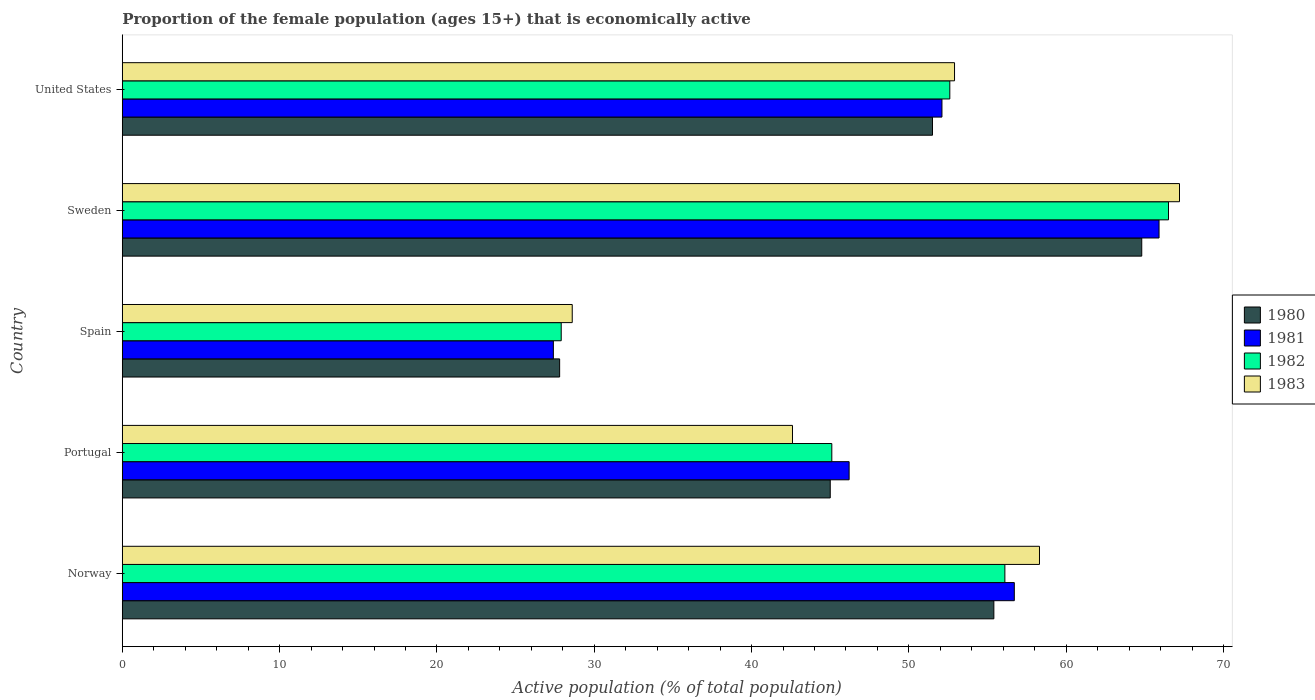How many groups of bars are there?
Your response must be concise. 5. Are the number of bars on each tick of the Y-axis equal?
Provide a short and direct response. Yes. How many bars are there on the 3rd tick from the bottom?
Offer a very short reply. 4. What is the label of the 4th group of bars from the top?
Your answer should be very brief. Portugal. In how many cases, is the number of bars for a given country not equal to the number of legend labels?
Keep it short and to the point. 0. What is the proportion of the female population that is economically active in 1980 in Norway?
Your answer should be very brief. 55.4. Across all countries, what is the maximum proportion of the female population that is economically active in 1980?
Offer a very short reply. 64.8. Across all countries, what is the minimum proportion of the female population that is economically active in 1981?
Give a very brief answer. 27.4. In which country was the proportion of the female population that is economically active in 1982 maximum?
Your answer should be very brief. Sweden. In which country was the proportion of the female population that is economically active in 1981 minimum?
Offer a very short reply. Spain. What is the total proportion of the female population that is economically active in 1982 in the graph?
Provide a succinct answer. 248.2. What is the difference between the proportion of the female population that is economically active in 1982 in Portugal and that in United States?
Your answer should be compact. -7.5. What is the difference between the proportion of the female population that is economically active in 1981 in United States and the proportion of the female population that is economically active in 1983 in Norway?
Your response must be concise. -6.2. What is the average proportion of the female population that is economically active in 1983 per country?
Provide a short and direct response. 49.92. What is the difference between the proportion of the female population that is economically active in 1983 and proportion of the female population that is economically active in 1982 in Norway?
Ensure brevity in your answer.  2.2. In how many countries, is the proportion of the female population that is economically active in 1982 greater than 42 %?
Ensure brevity in your answer.  4. What is the ratio of the proportion of the female population that is economically active in 1980 in Portugal to that in Sweden?
Keep it short and to the point. 0.69. What is the difference between the highest and the second highest proportion of the female population that is economically active in 1981?
Your answer should be compact. 9.2. What is the difference between the highest and the lowest proportion of the female population that is economically active in 1982?
Give a very brief answer. 38.6. In how many countries, is the proportion of the female population that is economically active in 1983 greater than the average proportion of the female population that is economically active in 1983 taken over all countries?
Provide a short and direct response. 3. What does the 2nd bar from the bottom in Sweden represents?
Provide a succinct answer. 1981. Is it the case that in every country, the sum of the proportion of the female population that is economically active in 1981 and proportion of the female population that is economically active in 1980 is greater than the proportion of the female population that is economically active in 1982?
Give a very brief answer. Yes. Are all the bars in the graph horizontal?
Offer a very short reply. Yes. Does the graph contain grids?
Your answer should be very brief. No. Where does the legend appear in the graph?
Your answer should be compact. Center right. How many legend labels are there?
Offer a terse response. 4. How are the legend labels stacked?
Your answer should be very brief. Vertical. What is the title of the graph?
Offer a very short reply. Proportion of the female population (ages 15+) that is economically active. Does "2004" appear as one of the legend labels in the graph?
Provide a short and direct response. No. What is the label or title of the X-axis?
Your answer should be compact. Active population (% of total population). What is the Active population (% of total population) in 1980 in Norway?
Offer a terse response. 55.4. What is the Active population (% of total population) in 1981 in Norway?
Keep it short and to the point. 56.7. What is the Active population (% of total population) in 1982 in Norway?
Offer a very short reply. 56.1. What is the Active population (% of total population) in 1983 in Norway?
Your response must be concise. 58.3. What is the Active population (% of total population) in 1980 in Portugal?
Provide a short and direct response. 45. What is the Active population (% of total population) of 1981 in Portugal?
Provide a succinct answer. 46.2. What is the Active population (% of total population) in 1982 in Portugal?
Make the answer very short. 45.1. What is the Active population (% of total population) in 1983 in Portugal?
Your answer should be very brief. 42.6. What is the Active population (% of total population) in 1980 in Spain?
Your answer should be very brief. 27.8. What is the Active population (% of total population) of 1981 in Spain?
Keep it short and to the point. 27.4. What is the Active population (% of total population) in 1982 in Spain?
Provide a short and direct response. 27.9. What is the Active population (% of total population) of 1983 in Spain?
Your response must be concise. 28.6. What is the Active population (% of total population) of 1980 in Sweden?
Keep it short and to the point. 64.8. What is the Active population (% of total population) of 1981 in Sweden?
Keep it short and to the point. 65.9. What is the Active population (% of total population) of 1982 in Sweden?
Provide a succinct answer. 66.5. What is the Active population (% of total population) of 1983 in Sweden?
Your answer should be very brief. 67.2. What is the Active population (% of total population) in 1980 in United States?
Provide a succinct answer. 51.5. What is the Active population (% of total population) in 1981 in United States?
Keep it short and to the point. 52.1. What is the Active population (% of total population) of 1982 in United States?
Your response must be concise. 52.6. What is the Active population (% of total population) in 1983 in United States?
Ensure brevity in your answer.  52.9. Across all countries, what is the maximum Active population (% of total population) in 1980?
Ensure brevity in your answer.  64.8. Across all countries, what is the maximum Active population (% of total population) of 1981?
Provide a short and direct response. 65.9. Across all countries, what is the maximum Active population (% of total population) in 1982?
Offer a very short reply. 66.5. Across all countries, what is the maximum Active population (% of total population) of 1983?
Your answer should be compact. 67.2. Across all countries, what is the minimum Active population (% of total population) in 1980?
Your response must be concise. 27.8. Across all countries, what is the minimum Active population (% of total population) of 1981?
Make the answer very short. 27.4. Across all countries, what is the minimum Active population (% of total population) of 1982?
Give a very brief answer. 27.9. Across all countries, what is the minimum Active population (% of total population) in 1983?
Provide a short and direct response. 28.6. What is the total Active population (% of total population) in 1980 in the graph?
Your answer should be very brief. 244.5. What is the total Active population (% of total population) of 1981 in the graph?
Your response must be concise. 248.3. What is the total Active population (% of total population) in 1982 in the graph?
Keep it short and to the point. 248.2. What is the total Active population (% of total population) in 1983 in the graph?
Offer a terse response. 249.6. What is the difference between the Active population (% of total population) of 1982 in Norway and that in Portugal?
Your answer should be very brief. 11. What is the difference between the Active population (% of total population) of 1980 in Norway and that in Spain?
Your answer should be very brief. 27.6. What is the difference between the Active population (% of total population) in 1981 in Norway and that in Spain?
Provide a short and direct response. 29.3. What is the difference between the Active population (% of total population) of 1982 in Norway and that in Spain?
Keep it short and to the point. 28.2. What is the difference between the Active population (% of total population) in 1983 in Norway and that in Spain?
Provide a succinct answer. 29.7. What is the difference between the Active population (% of total population) in 1980 in Norway and that in Sweden?
Offer a very short reply. -9.4. What is the difference between the Active population (% of total population) in 1981 in Norway and that in Sweden?
Your response must be concise. -9.2. What is the difference between the Active population (% of total population) of 1983 in Norway and that in Sweden?
Provide a succinct answer. -8.9. What is the difference between the Active population (% of total population) in 1981 in Norway and that in United States?
Your answer should be very brief. 4.6. What is the difference between the Active population (% of total population) in 1980 in Portugal and that in Sweden?
Offer a very short reply. -19.8. What is the difference between the Active population (% of total population) in 1981 in Portugal and that in Sweden?
Keep it short and to the point. -19.7. What is the difference between the Active population (% of total population) in 1982 in Portugal and that in Sweden?
Keep it short and to the point. -21.4. What is the difference between the Active population (% of total population) in 1983 in Portugal and that in Sweden?
Provide a succinct answer. -24.6. What is the difference between the Active population (% of total population) in 1980 in Portugal and that in United States?
Offer a very short reply. -6.5. What is the difference between the Active population (% of total population) of 1981 in Portugal and that in United States?
Your answer should be compact. -5.9. What is the difference between the Active population (% of total population) in 1982 in Portugal and that in United States?
Provide a succinct answer. -7.5. What is the difference between the Active population (% of total population) in 1983 in Portugal and that in United States?
Keep it short and to the point. -10.3. What is the difference between the Active population (% of total population) in 1980 in Spain and that in Sweden?
Ensure brevity in your answer.  -37. What is the difference between the Active population (% of total population) of 1981 in Spain and that in Sweden?
Provide a short and direct response. -38.5. What is the difference between the Active population (% of total population) in 1982 in Spain and that in Sweden?
Offer a very short reply. -38.6. What is the difference between the Active population (% of total population) in 1983 in Spain and that in Sweden?
Your answer should be compact. -38.6. What is the difference between the Active population (% of total population) in 1980 in Spain and that in United States?
Provide a succinct answer. -23.7. What is the difference between the Active population (% of total population) of 1981 in Spain and that in United States?
Offer a terse response. -24.7. What is the difference between the Active population (% of total population) of 1982 in Spain and that in United States?
Provide a succinct answer. -24.7. What is the difference between the Active population (% of total population) of 1983 in Spain and that in United States?
Provide a succinct answer. -24.3. What is the difference between the Active population (% of total population) in 1980 in Sweden and that in United States?
Your response must be concise. 13.3. What is the difference between the Active population (% of total population) in 1981 in Sweden and that in United States?
Your response must be concise. 13.8. What is the difference between the Active population (% of total population) of 1983 in Sweden and that in United States?
Provide a succinct answer. 14.3. What is the difference between the Active population (% of total population) in 1980 in Norway and the Active population (% of total population) in 1982 in Portugal?
Your answer should be compact. 10.3. What is the difference between the Active population (% of total population) in 1980 in Norway and the Active population (% of total population) in 1983 in Portugal?
Your response must be concise. 12.8. What is the difference between the Active population (% of total population) in 1981 in Norway and the Active population (% of total population) in 1982 in Portugal?
Offer a terse response. 11.6. What is the difference between the Active population (% of total population) in 1982 in Norway and the Active population (% of total population) in 1983 in Portugal?
Your answer should be compact. 13.5. What is the difference between the Active population (% of total population) in 1980 in Norway and the Active population (% of total population) in 1982 in Spain?
Your answer should be very brief. 27.5. What is the difference between the Active population (% of total population) in 1980 in Norway and the Active population (% of total population) in 1983 in Spain?
Keep it short and to the point. 26.8. What is the difference between the Active population (% of total population) in 1981 in Norway and the Active population (% of total population) in 1982 in Spain?
Your response must be concise. 28.8. What is the difference between the Active population (% of total population) in 1981 in Norway and the Active population (% of total population) in 1983 in Spain?
Give a very brief answer. 28.1. What is the difference between the Active population (% of total population) in 1980 in Norway and the Active population (% of total population) in 1981 in Sweden?
Your response must be concise. -10.5. What is the difference between the Active population (% of total population) in 1981 in Norway and the Active population (% of total population) in 1982 in Sweden?
Keep it short and to the point. -9.8. What is the difference between the Active population (% of total population) of 1982 in Norway and the Active population (% of total population) of 1983 in Sweden?
Give a very brief answer. -11.1. What is the difference between the Active population (% of total population) of 1980 in Norway and the Active population (% of total population) of 1981 in United States?
Your answer should be very brief. 3.3. What is the difference between the Active population (% of total population) in 1980 in Norway and the Active population (% of total population) in 1982 in United States?
Your response must be concise. 2.8. What is the difference between the Active population (% of total population) of 1981 in Norway and the Active population (% of total population) of 1982 in United States?
Your answer should be very brief. 4.1. What is the difference between the Active population (% of total population) of 1982 in Norway and the Active population (% of total population) of 1983 in United States?
Offer a very short reply. 3.2. What is the difference between the Active population (% of total population) in 1980 in Portugal and the Active population (% of total population) in 1981 in Spain?
Provide a short and direct response. 17.6. What is the difference between the Active population (% of total population) of 1982 in Portugal and the Active population (% of total population) of 1983 in Spain?
Make the answer very short. 16.5. What is the difference between the Active population (% of total population) in 1980 in Portugal and the Active population (% of total population) in 1981 in Sweden?
Make the answer very short. -20.9. What is the difference between the Active population (% of total population) in 1980 in Portugal and the Active population (% of total population) in 1982 in Sweden?
Ensure brevity in your answer.  -21.5. What is the difference between the Active population (% of total population) in 1980 in Portugal and the Active population (% of total population) in 1983 in Sweden?
Offer a very short reply. -22.2. What is the difference between the Active population (% of total population) in 1981 in Portugal and the Active population (% of total population) in 1982 in Sweden?
Keep it short and to the point. -20.3. What is the difference between the Active population (% of total population) in 1981 in Portugal and the Active population (% of total population) in 1983 in Sweden?
Provide a succinct answer. -21. What is the difference between the Active population (% of total population) of 1982 in Portugal and the Active population (% of total population) of 1983 in Sweden?
Your response must be concise. -22.1. What is the difference between the Active population (% of total population) in 1980 in Portugal and the Active population (% of total population) in 1981 in United States?
Your answer should be compact. -7.1. What is the difference between the Active population (% of total population) in 1980 in Portugal and the Active population (% of total population) in 1983 in United States?
Provide a short and direct response. -7.9. What is the difference between the Active population (% of total population) in 1981 in Portugal and the Active population (% of total population) in 1982 in United States?
Give a very brief answer. -6.4. What is the difference between the Active population (% of total population) of 1981 in Portugal and the Active population (% of total population) of 1983 in United States?
Make the answer very short. -6.7. What is the difference between the Active population (% of total population) in 1982 in Portugal and the Active population (% of total population) in 1983 in United States?
Give a very brief answer. -7.8. What is the difference between the Active population (% of total population) of 1980 in Spain and the Active population (% of total population) of 1981 in Sweden?
Provide a short and direct response. -38.1. What is the difference between the Active population (% of total population) of 1980 in Spain and the Active population (% of total population) of 1982 in Sweden?
Give a very brief answer. -38.7. What is the difference between the Active population (% of total population) in 1980 in Spain and the Active population (% of total population) in 1983 in Sweden?
Make the answer very short. -39.4. What is the difference between the Active population (% of total population) of 1981 in Spain and the Active population (% of total population) of 1982 in Sweden?
Provide a short and direct response. -39.1. What is the difference between the Active population (% of total population) in 1981 in Spain and the Active population (% of total population) in 1983 in Sweden?
Your answer should be compact. -39.8. What is the difference between the Active population (% of total population) in 1982 in Spain and the Active population (% of total population) in 1983 in Sweden?
Ensure brevity in your answer.  -39.3. What is the difference between the Active population (% of total population) in 1980 in Spain and the Active population (% of total population) in 1981 in United States?
Ensure brevity in your answer.  -24.3. What is the difference between the Active population (% of total population) of 1980 in Spain and the Active population (% of total population) of 1982 in United States?
Make the answer very short. -24.8. What is the difference between the Active population (% of total population) of 1980 in Spain and the Active population (% of total population) of 1983 in United States?
Your response must be concise. -25.1. What is the difference between the Active population (% of total population) in 1981 in Spain and the Active population (% of total population) in 1982 in United States?
Your answer should be very brief. -25.2. What is the difference between the Active population (% of total population) in 1981 in Spain and the Active population (% of total population) in 1983 in United States?
Provide a short and direct response. -25.5. What is the difference between the Active population (% of total population) in 1982 in Spain and the Active population (% of total population) in 1983 in United States?
Provide a short and direct response. -25. What is the difference between the Active population (% of total population) in 1980 in Sweden and the Active population (% of total population) in 1983 in United States?
Offer a very short reply. 11.9. What is the difference between the Active population (% of total population) in 1981 in Sweden and the Active population (% of total population) in 1983 in United States?
Give a very brief answer. 13. What is the average Active population (% of total population) in 1980 per country?
Your response must be concise. 48.9. What is the average Active population (% of total population) in 1981 per country?
Offer a terse response. 49.66. What is the average Active population (% of total population) in 1982 per country?
Make the answer very short. 49.64. What is the average Active population (% of total population) in 1983 per country?
Your answer should be very brief. 49.92. What is the difference between the Active population (% of total population) in 1980 and Active population (% of total population) in 1983 in Norway?
Keep it short and to the point. -2.9. What is the difference between the Active population (% of total population) in 1981 and Active population (% of total population) in 1983 in Norway?
Provide a succinct answer. -1.6. What is the difference between the Active population (% of total population) of 1982 and Active population (% of total population) of 1983 in Norway?
Offer a terse response. -2.2. What is the difference between the Active population (% of total population) in 1981 and Active population (% of total population) in 1982 in Portugal?
Your response must be concise. 1.1. What is the difference between the Active population (% of total population) of 1980 and Active population (% of total population) of 1981 in Spain?
Your answer should be compact. 0.4. What is the difference between the Active population (% of total population) of 1980 and Active population (% of total population) of 1982 in Spain?
Ensure brevity in your answer.  -0.1. What is the difference between the Active population (% of total population) of 1981 and Active population (% of total population) of 1983 in Spain?
Offer a very short reply. -1.2. What is the difference between the Active population (% of total population) of 1980 and Active population (% of total population) of 1982 in Sweden?
Provide a short and direct response. -1.7. What is the difference between the Active population (% of total population) of 1981 and Active population (% of total population) of 1983 in Sweden?
Ensure brevity in your answer.  -1.3. What is the difference between the Active population (% of total population) of 1980 and Active population (% of total population) of 1981 in United States?
Provide a short and direct response. -0.6. What is the difference between the Active population (% of total population) in 1982 and Active population (% of total population) in 1983 in United States?
Keep it short and to the point. -0.3. What is the ratio of the Active population (% of total population) in 1980 in Norway to that in Portugal?
Keep it short and to the point. 1.23. What is the ratio of the Active population (% of total population) in 1981 in Norway to that in Portugal?
Provide a short and direct response. 1.23. What is the ratio of the Active population (% of total population) of 1982 in Norway to that in Portugal?
Your answer should be very brief. 1.24. What is the ratio of the Active population (% of total population) of 1983 in Norway to that in Portugal?
Provide a short and direct response. 1.37. What is the ratio of the Active population (% of total population) in 1980 in Norway to that in Spain?
Your response must be concise. 1.99. What is the ratio of the Active population (% of total population) of 1981 in Norway to that in Spain?
Provide a succinct answer. 2.07. What is the ratio of the Active population (% of total population) in 1982 in Norway to that in Spain?
Make the answer very short. 2.01. What is the ratio of the Active population (% of total population) in 1983 in Norway to that in Spain?
Make the answer very short. 2.04. What is the ratio of the Active population (% of total population) in 1980 in Norway to that in Sweden?
Ensure brevity in your answer.  0.85. What is the ratio of the Active population (% of total population) of 1981 in Norway to that in Sweden?
Your answer should be compact. 0.86. What is the ratio of the Active population (% of total population) of 1982 in Norway to that in Sweden?
Keep it short and to the point. 0.84. What is the ratio of the Active population (% of total population) in 1983 in Norway to that in Sweden?
Ensure brevity in your answer.  0.87. What is the ratio of the Active population (% of total population) in 1980 in Norway to that in United States?
Offer a very short reply. 1.08. What is the ratio of the Active population (% of total population) of 1981 in Norway to that in United States?
Make the answer very short. 1.09. What is the ratio of the Active population (% of total population) in 1982 in Norway to that in United States?
Your answer should be very brief. 1.07. What is the ratio of the Active population (% of total population) in 1983 in Norway to that in United States?
Keep it short and to the point. 1.1. What is the ratio of the Active population (% of total population) of 1980 in Portugal to that in Spain?
Offer a very short reply. 1.62. What is the ratio of the Active population (% of total population) of 1981 in Portugal to that in Spain?
Your answer should be very brief. 1.69. What is the ratio of the Active population (% of total population) of 1982 in Portugal to that in Spain?
Give a very brief answer. 1.62. What is the ratio of the Active population (% of total population) of 1983 in Portugal to that in Spain?
Keep it short and to the point. 1.49. What is the ratio of the Active population (% of total population) in 1980 in Portugal to that in Sweden?
Your answer should be compact. 0.69. What is the ratio of the Active population (% of total population) of 1981 in Portugal to that in Sweden?
Keep it short and to the point. 0.7. What is the ratio of the Active population (% of total population) of 1982 in Portugal to that in Sweden?
Your response must be concise. 0.68. What is the ratio of the Active population (% of total population) of 1983 in Portugal to that in Sweden?
Your response must be concise. 0.63. What is the ratio of the Active population (% of total population) in 1980 in Portugal to that in United States?
Your response must be concise. 0.87. What is the ratio of the Active population (% of total population) of 1981 in Portugal to that in United States?
Make the answer very short. 0.89. What is the ratio of the Active population (% of total population) of 1982 in Portugal to that in United States?
Make the answer very short. 0.86. What is the ratio of the Active population (% of total population) of 1983 in Portugal to that in United States?
Ensure brevity in your answer.  0.81. What is the ratio of the Active population (% of total population) of 1980 in Spain to that in Sweden?
Offer a very short reply. 0.43. What is the ratio of the Active population (% of total population) of 1981 in Spain to that in Sweden?
Keep it short and to the point. 0.42. What is the ratio of the Active population (% of total population) in 1982 in Spain to that in Sweden?
Provide a short and direct response. 0.42. What is the ratio of the Active population (% of total population) in 1983 in Spain to that in Sweden?
Provide a succinct answer. 0.43. What is the ratio of the Active population (% of total population) of 1980 in Spain to that in United States?
Provide a short and direct response. 0.54. What is the ratio of the Active population (% of total population) of 1981 in Spain to that in United States?
Offer a very short reply. 0.53. What is the ratio of the Active population (% of total population) in 1982 in Spain to that in United States?
Ensure brevity in your answer.  0.53. What is the ratio of the Active population (% of total population) in 1983 in Spain to that in United States?
Provide a short and direct response. 0.54. What is the ratio of the Active population (% of total population) of 1980 in Sweden to that in United States?
Your answer should be compact. 1.26. What is the ratio of the Active population (% of total population) of 1981 in Sweden to that in United States?
Your answer should be compact. 1.26. What is the ratio of the Active population (% of total population) in 1982 in Sweden to that in United States?
Offer a very short reply. 1.26. What is the ratio of the Active population (% of total population) in 1983 in Sweden to that in United States?
Your answer should be compact. 1.27. What is the difference between the highest and the second highest Active population (% of total population) of 1980?
Your answer should be compact. 9.4. What is the difference between the highest and the second highest Active population (% of total population) of 1981?
Offer a terse response. 9.2. What is the difference between the highest and the lowest Active population (% of total population) in 1980?
Ensure brevity in your answer.  37. What is the difference between the highest and the lowest Active population (% of total population) of 1981?
Make the answer very short. 38.5. What is the difference between the highest and the lowest Active population (% of total population) in 1982?
Your answer should be very brief. 38.6. What is the difference between the highest and the lowest Active population (% of total population) in 1983?
Give a very brief answer. 38.6. 